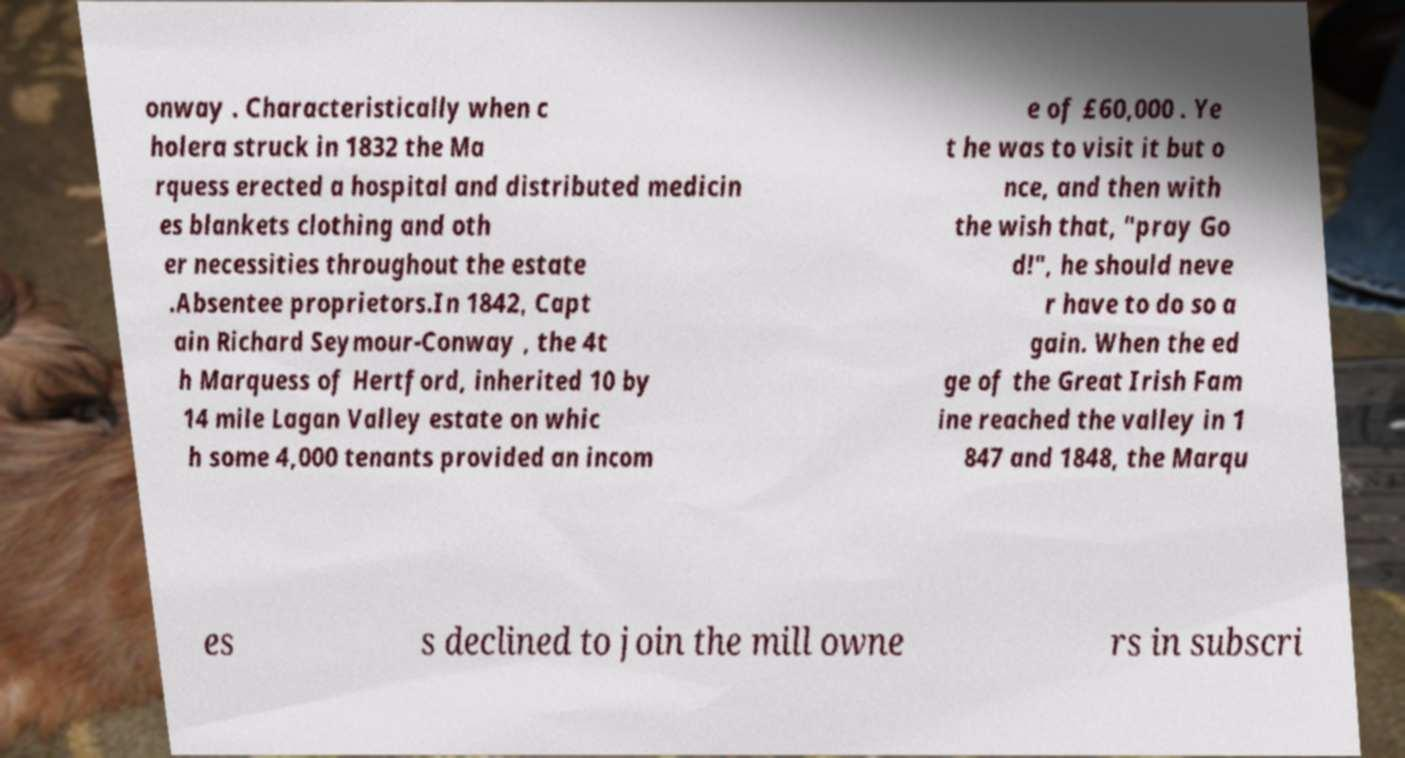I need the written content from this picture converted into text. Can you do that? onway . Characteristically when c holera struck in 1832 the Ma rquess erected a hospital and distributed medicin es blankets clothing and oth er necessities throughout the estate .Absentee proprietors.In 1842, Capt ain Richard Seymour-Conway , the 4t h Marquess of Hertford, inherited 10 by 14 mile Lagan Valley estate on whic h some 4,000 tenants provided an incom e of £60,000 . Ye t he was to visit it but o nce, and then with the wish that, "pray Go d!", he should neve r have to do so a gain. When the ed ge of the Great Irish Fam ine reached the valley in 1 847 and 1848, the Marqu es s declined to join the mill owne rs in subscri 